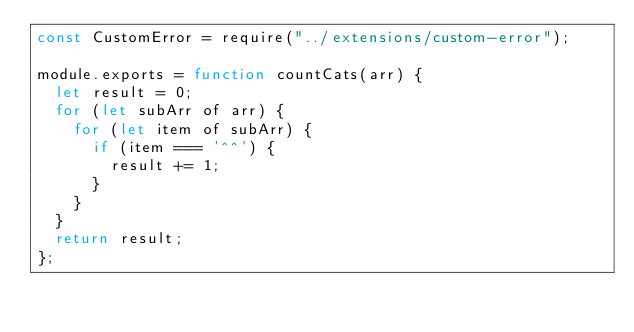Convert code to text. <code><loc_0><loc_0><loc_500><loc_500><_JavaScript_>const CustomError = require("../extensions/custom-error");

module.exports = function countCats(arr) {
  let result = 0;
  for (let subArr of arr) {
    for (let item of subArr) {
      if (item === '^^') {
        result += 1;
      }
    }
  }
  return result;
};
</code> 